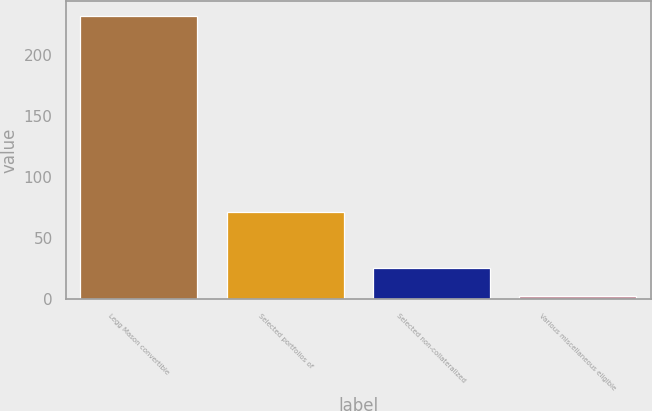Convert chart. <chart><loc_0><loc_0><loc_500><loc_500><bar_chart><fcel>Legg Mason convertible<fcel>Selected portfolios of<fcel>Selected non-collateralized<fcel>Various miscellaneous eligible<nl><fcel>232<fcel>71.7<fcel>25.9<fcel>3<nl></chart> 